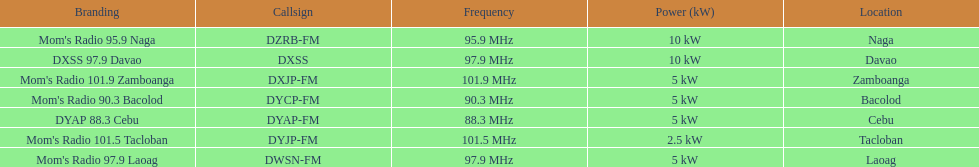How many stations have at least 5 kw or more listed in the power column? 6. 